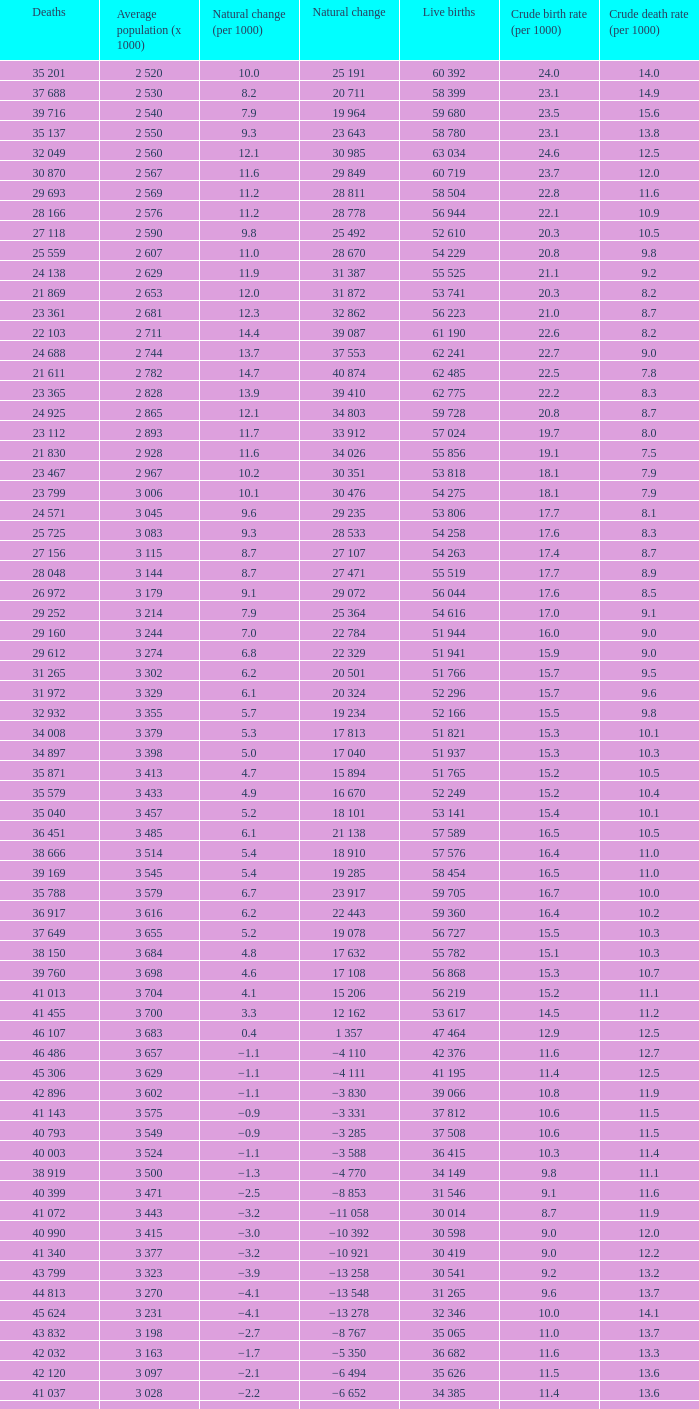Which Live births have a Natural change (per 1000) of 12.0? 53 741. 